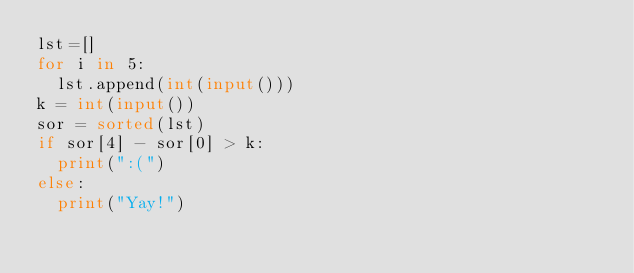Convert code to text. <code><loc_0><loc_0><loc_500><loc_500><_Python_>lst=[]
for i in 5:
	lst.append(int(input()))
k = int(input())
sor = sorted(lst)
if sor[4] - sor[0] > k:
	print(":(")
else:
	print("Yay!")
</code> 